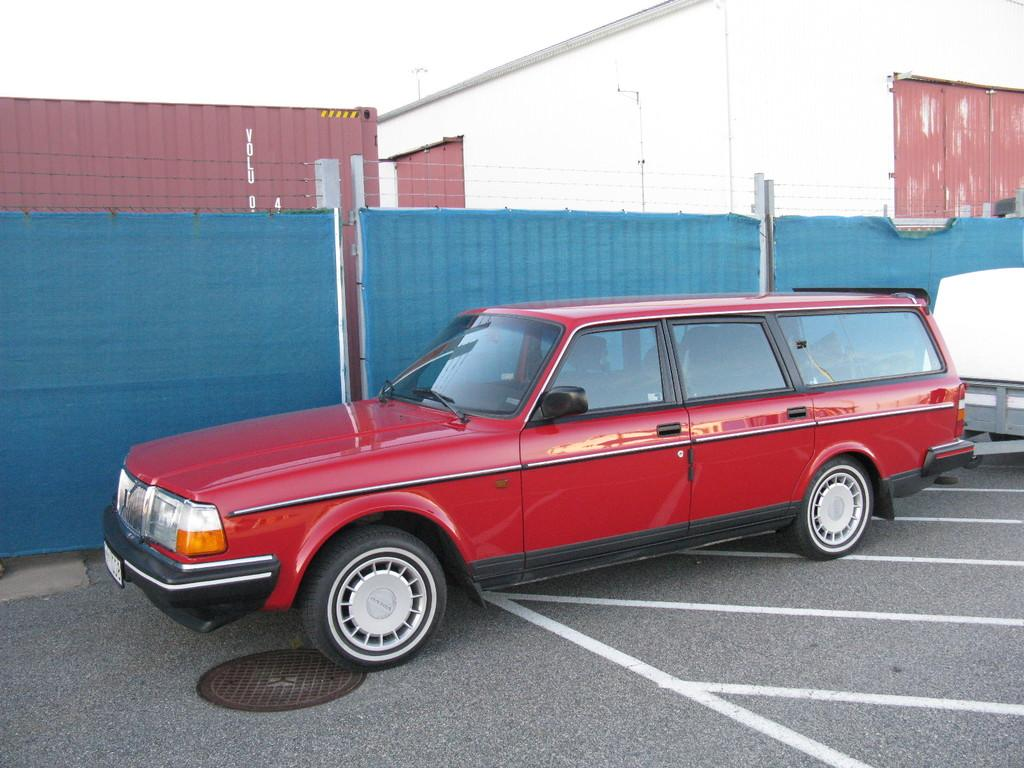What is the main subject of the image? The main subject of the image is a car. Can you describe the car in the image? The car is red. What else can be seen in the image besides the car? There is fencing in the image. Are there any other objects or features around the car and fencing? There are other unspecified things around the car and fencing. What is the rate of the writer's productivity in the image? There is no writer or productivity rate mentioned in the image; it features a red car and fencing. How many cows are visible in the image? There are no cows present in the image. 